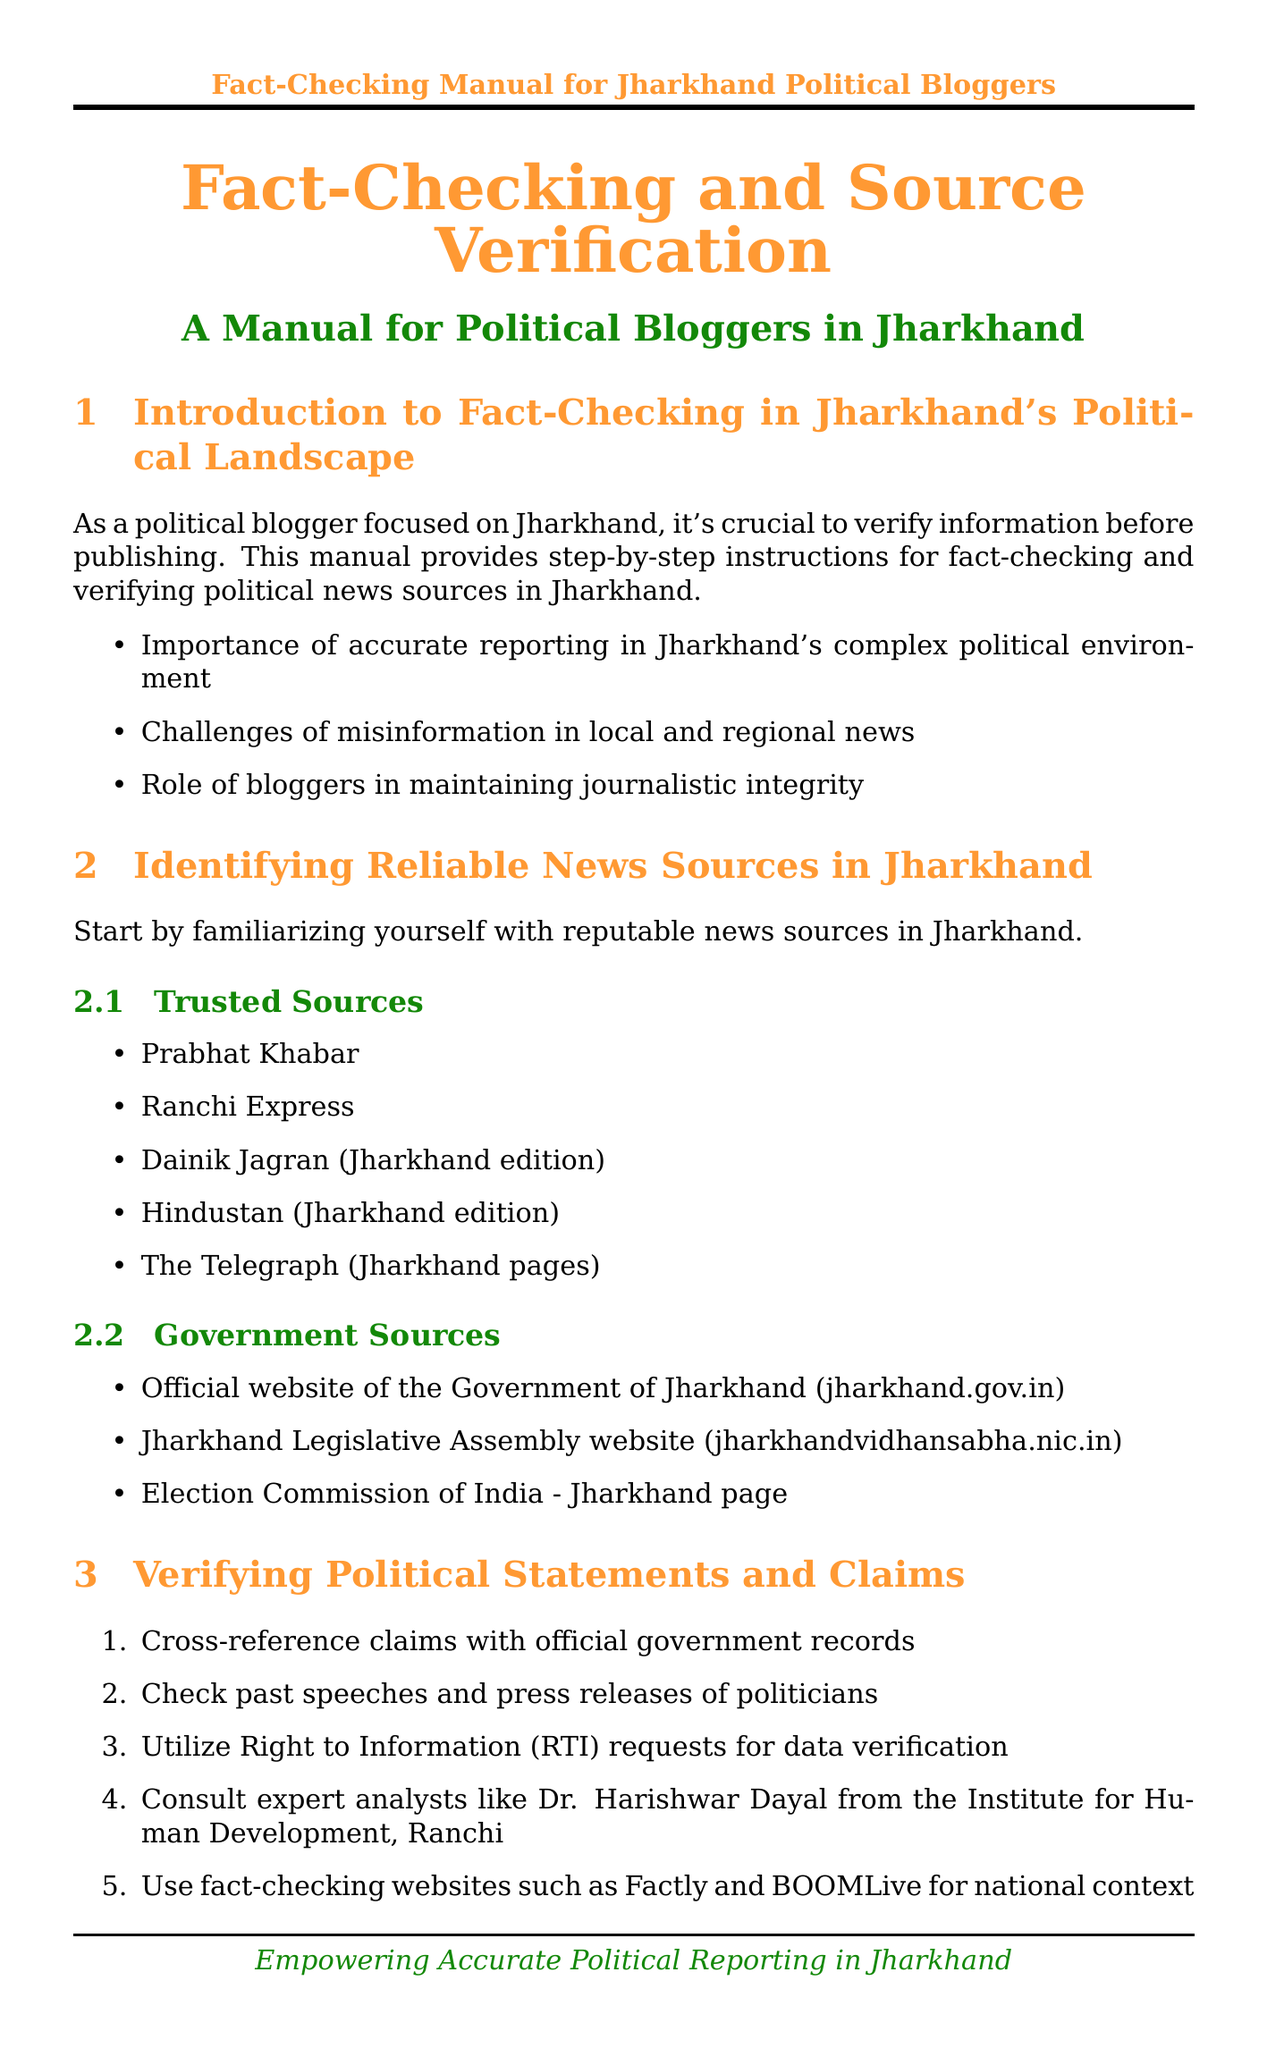What is the title of the manual? The title of the manual is explicitly stated at the beginning of the document.
Answer: Fact-Checking and Source Verification How many trusted news sources are listed? The number of trusted news sources is determined by counting the items under the "Trusted Sources" section.
Answer: Five Which website provides official statements for Jharkhand? This information can be found in the section concerning contacting primary sources, which lists relevant sources.
Answer: Jharkhand Public Relations Department What is one method for verifying political statements? The document outlines several steps in the "Verifying Political Statements and Claims" section, one of which is highlighted.
Answer: Cross-reference claims with official government records What social media platform is recommended for tracking content spread? The relevant section on social media discusses various platforms and their uses in fact-checking.
Answer: Facebook Who is an expert analyst mentioned in the document? The document names specific individuals relevant to fact-checking, highlighting an expert.
Answer: Dr. Harishwar Dayal What is the purpose of the Election Commission of India's Voter Helpline App? The purpose is stated within the "Fact-Checking Tools and Resources" section, explaining its function.
Answer: Verify voter information and election-related data What should bloggers strive for when reporting? This principle is mentioned in the conclusion, summarizing an essential practice for bloggers.
Answer: Accuracy over speed 